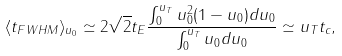<formula> <loc_0><loc_0><loc_500><loc_500>\langle t _ { F W H M } \rangle _ { u _ { 0 } } \simeq 2 \sqrt { 2 } t _ { E } \frac { \int _ { 0 } ^ { u _ { T } } u _ { 0 } ^ { 2 } ( 1 - u _ { 0 } ) d u _ { 0 } } { \int _ { 0 } ^ { u _ { T } } u _ { 0 } d u _ { 0 } } \simeq u _ { T } t _ { c } ,</formula> 